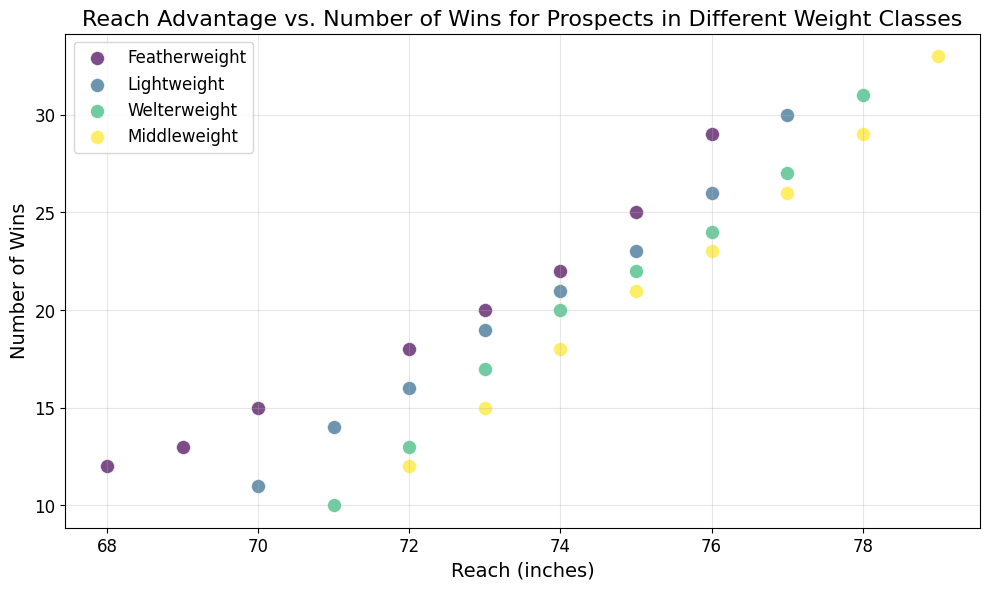Which weight class has the boxer with the highest number of wins? The boxer with the highest number of wins is located at the top of the scatter plot. The point at the highest position along the y-axis has a "Welterweight" color (usually dark yellow in most color maps). This indicates that the boxer with the highest number of wins belongs to the Welterweight weight class.
Answer: Welterweight What is the range of reaches for the Featherweight class? The range of a data set is obtained by finding the difference between the maximum and minimum values. For the Featherweight class on the x-axis (representing reaches), the minimum reach is 68 inches and the maximum reach is 76 inches. Therefore, the range is 76 - 68 = 8 inches.
Answer: 8 inches Which weight class has the widest spread in reach values? To determine the weight class with the widest spread, visually assess the horizontal spread of each color representing different classes. The Welterweight class, represented by the color ranging from 71 inches to 78 inches on the x-axis, has the widest spread of reach values.
Answer: Welterweight Is there a weight class where all boxers have more than 20 wins? To answer this question, visually assess the lowest position on the y-axis (representing wins) for each color representing a weight class. The Middleweight class always starts at a y-value above 20 wins, indicating that all Middleweight class boxers have more than 20 wins.
Answer: Middleweight Compare the maximum reaches of Featherweight and Middleweight classes. Which one is greater? To compare, find the maximum reach for both Featherweight and Middleweight classes along the x-axis. The maximum reach for Featherweight (yellow points) is 76 inches, while for Middleweight (green points) it is 79 inches. Hence, the maximum reach is greater for Middleweight class.
Answer: Middleweight What is the average number of wins for boxers in the Lightweight class? To find the average, sum up all the wins for Lightweight boxers and divide by the number of data points. Summing them gives 11+14+16+19+21+23+26+30 = 160. There are 8 data points, so the average is 160 / 8 = 20 wins.
Answer: 20 wins Identify the weight class with the smallest range in the number of wins. To identify the smallest range in the number of wins, examine the vertical spread for each color. The Featherweight class, which ranges from 12 to 29 wins, has the smallest spread compared to the others. Therefore, the range is 29 - 12 = 17 wins, which is smaller than the range for other classes.
Answer: Featherweight In which weight class, the smallest reach corresponds to the largest number of wins? Look at the rightmost point along the y-axis (highest wins) and find its corresponding x-value (reach) for each weight class. For Welterweight, the boxer with the largest number of wins has a reach of 78 inches which is the smallest reach within its set.
Answer: Welterweight 